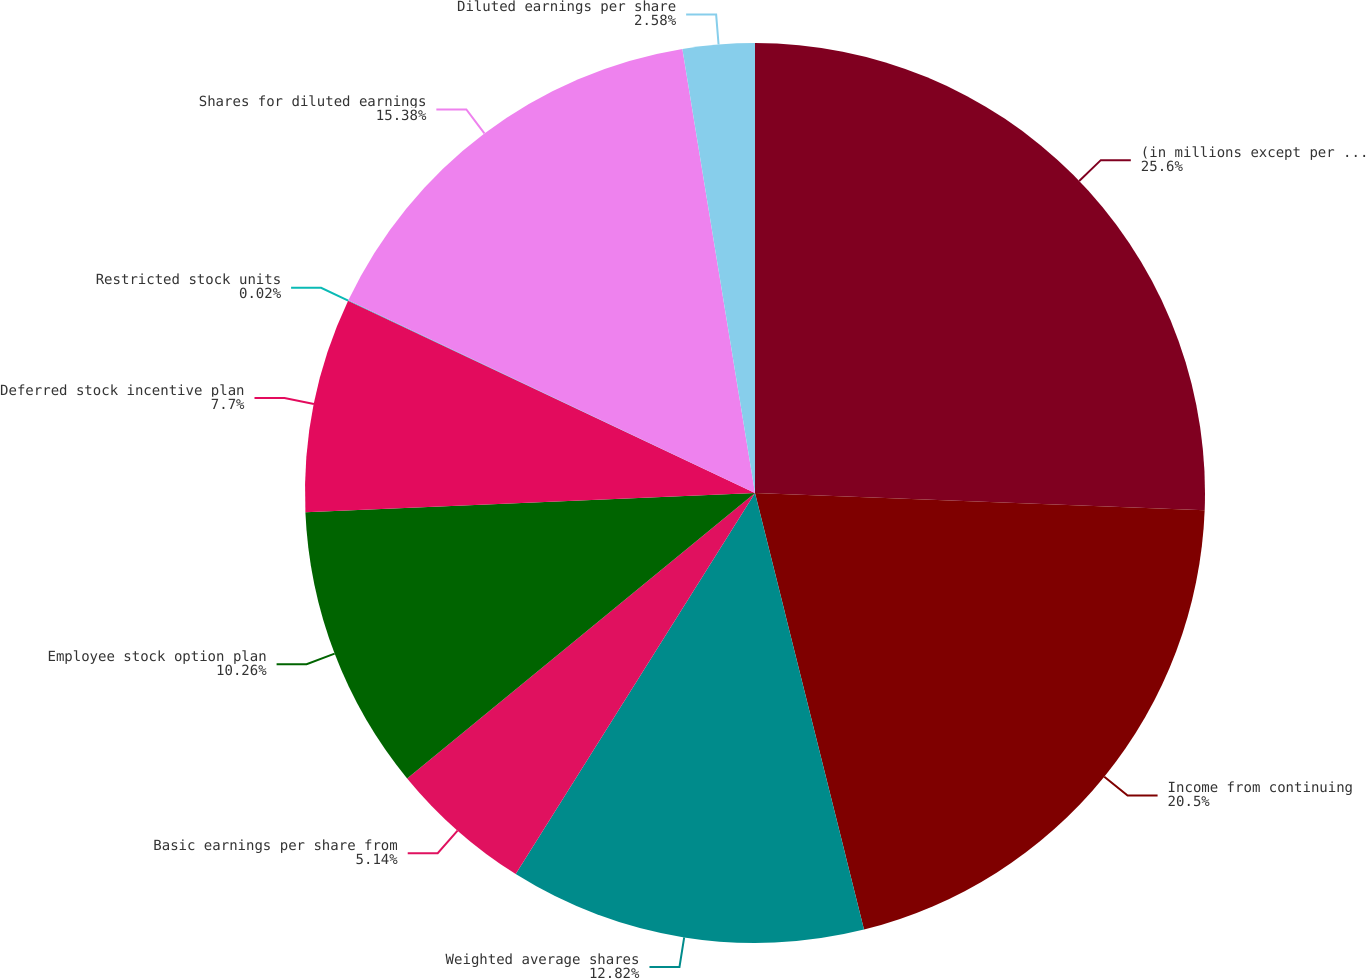Convert chart. <chart><loc_0><loc_0><loc_500><loc_500><pie_chart><fcel>(in millions except per share<fcel>Income from continuing<fcel>Weighted average shares<fcel>Basic earnings per share from<fcel>Employee stock option plan<fcel>Deferred stock incentive plan<fcel>Restricted stock units<fcel>Shares for diluted earnings<fcel>Diluted earnings per share<nl><fcel>25.61%<fcel>20.5%<fcel>12.82%<fcel>5.14%<fcel>10.26%<fcel>7.7%<fcel>0.02%<fcel>15.38%<fcel>2.58%<nl></chart> 